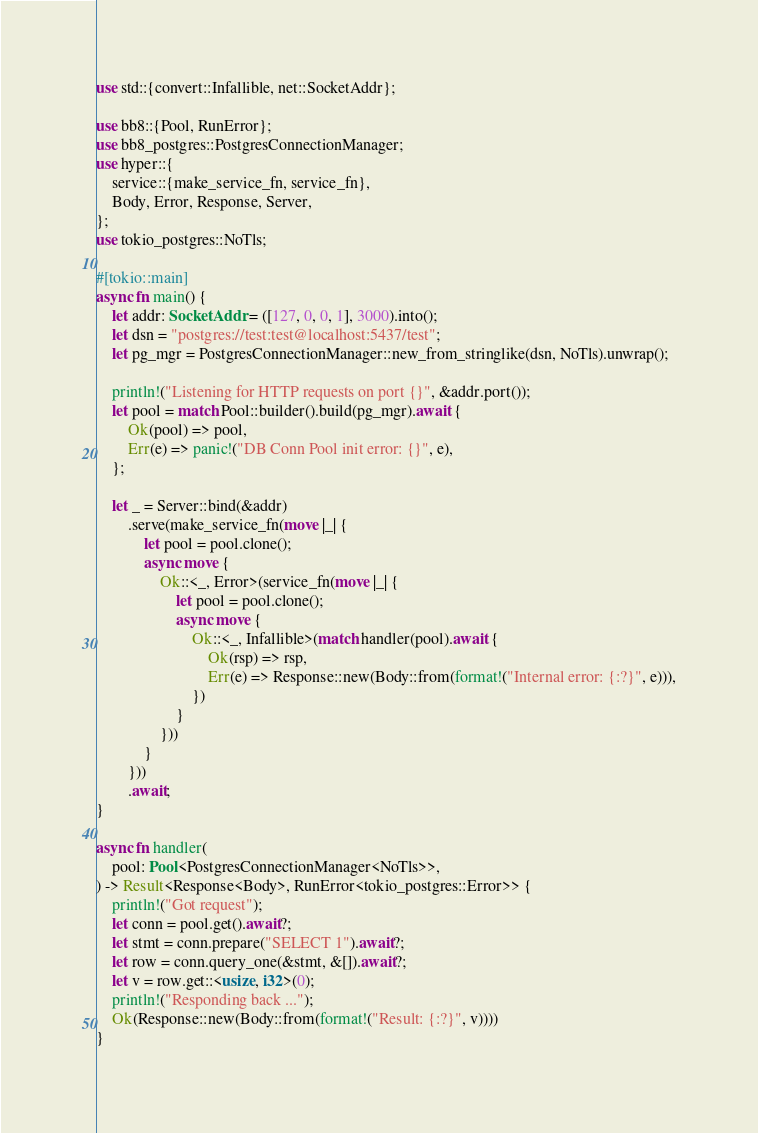<code> <loc_0><loc_0><loc_500><loc_500><_Rust_>use std::{convert::Infallible, net::SocketAddr};

use bb8::{Pool, RunError};
use bb8_postgres::PostgresConnectionManager;
use hyper::{
    service::{make_service_fn, service_fn},
    Body, Error, Response, Server,
};
use tokio_postgres::NoTls;

#[tokio::main]
async fn main() {
    let addr: SocketAddr = ([127, 0, 0, 1], 3000).into();
    let dsn = "postgres://test:test@localhost:5437/test";
    let pg_mgr = PostgresConnectionManager::new_from_stringlike(dsn, NoTls).unwrap();

    println!("Listening for HTTP requests on port {}", &addr.port());
    let pool = match Pool::builder().build(pg_mgr).await {
        Ok(pool) => pool,
        Err(e) => panic!("DB Conn Pool init error: {}", e),
    };

    let _ = Server::bind(&addr)
        .serve(make_service_fn(move |_| {
            let pool = pool.clone();
            async move {
                Ok::<_, Error>(service_fn(move |_| {
                    let pool = pool.clone();
                    async move {
                        Ok::<_, Infallible>(match handler(pool).await {
                            Ok(rsp) => rsp,
                            Err(e) => Response::new(Body::from(format!("Internal error: {:?}", e))),
                        })
                    }
                }))
            }
        }))
        .await;
}

async fn handler(
    pool: Pool<PostgresConnectionManager<NoTls>>,
) -> Result<Response<Body>, RunError<tokio_postgres::Error>> {
    println!("Got request");
    let conn = pool.get().await?;
    let stmt = conn.prepare("SELECT 1").await?;
    let row = conn.query_one(&stmt, &[]).await?;
    let v = row.get::<usize, i32>(0);
    println!("Responding back ...");
    Ok(Response::new(Body::from(format!("Result: {:?}", v))))
}
</code> 